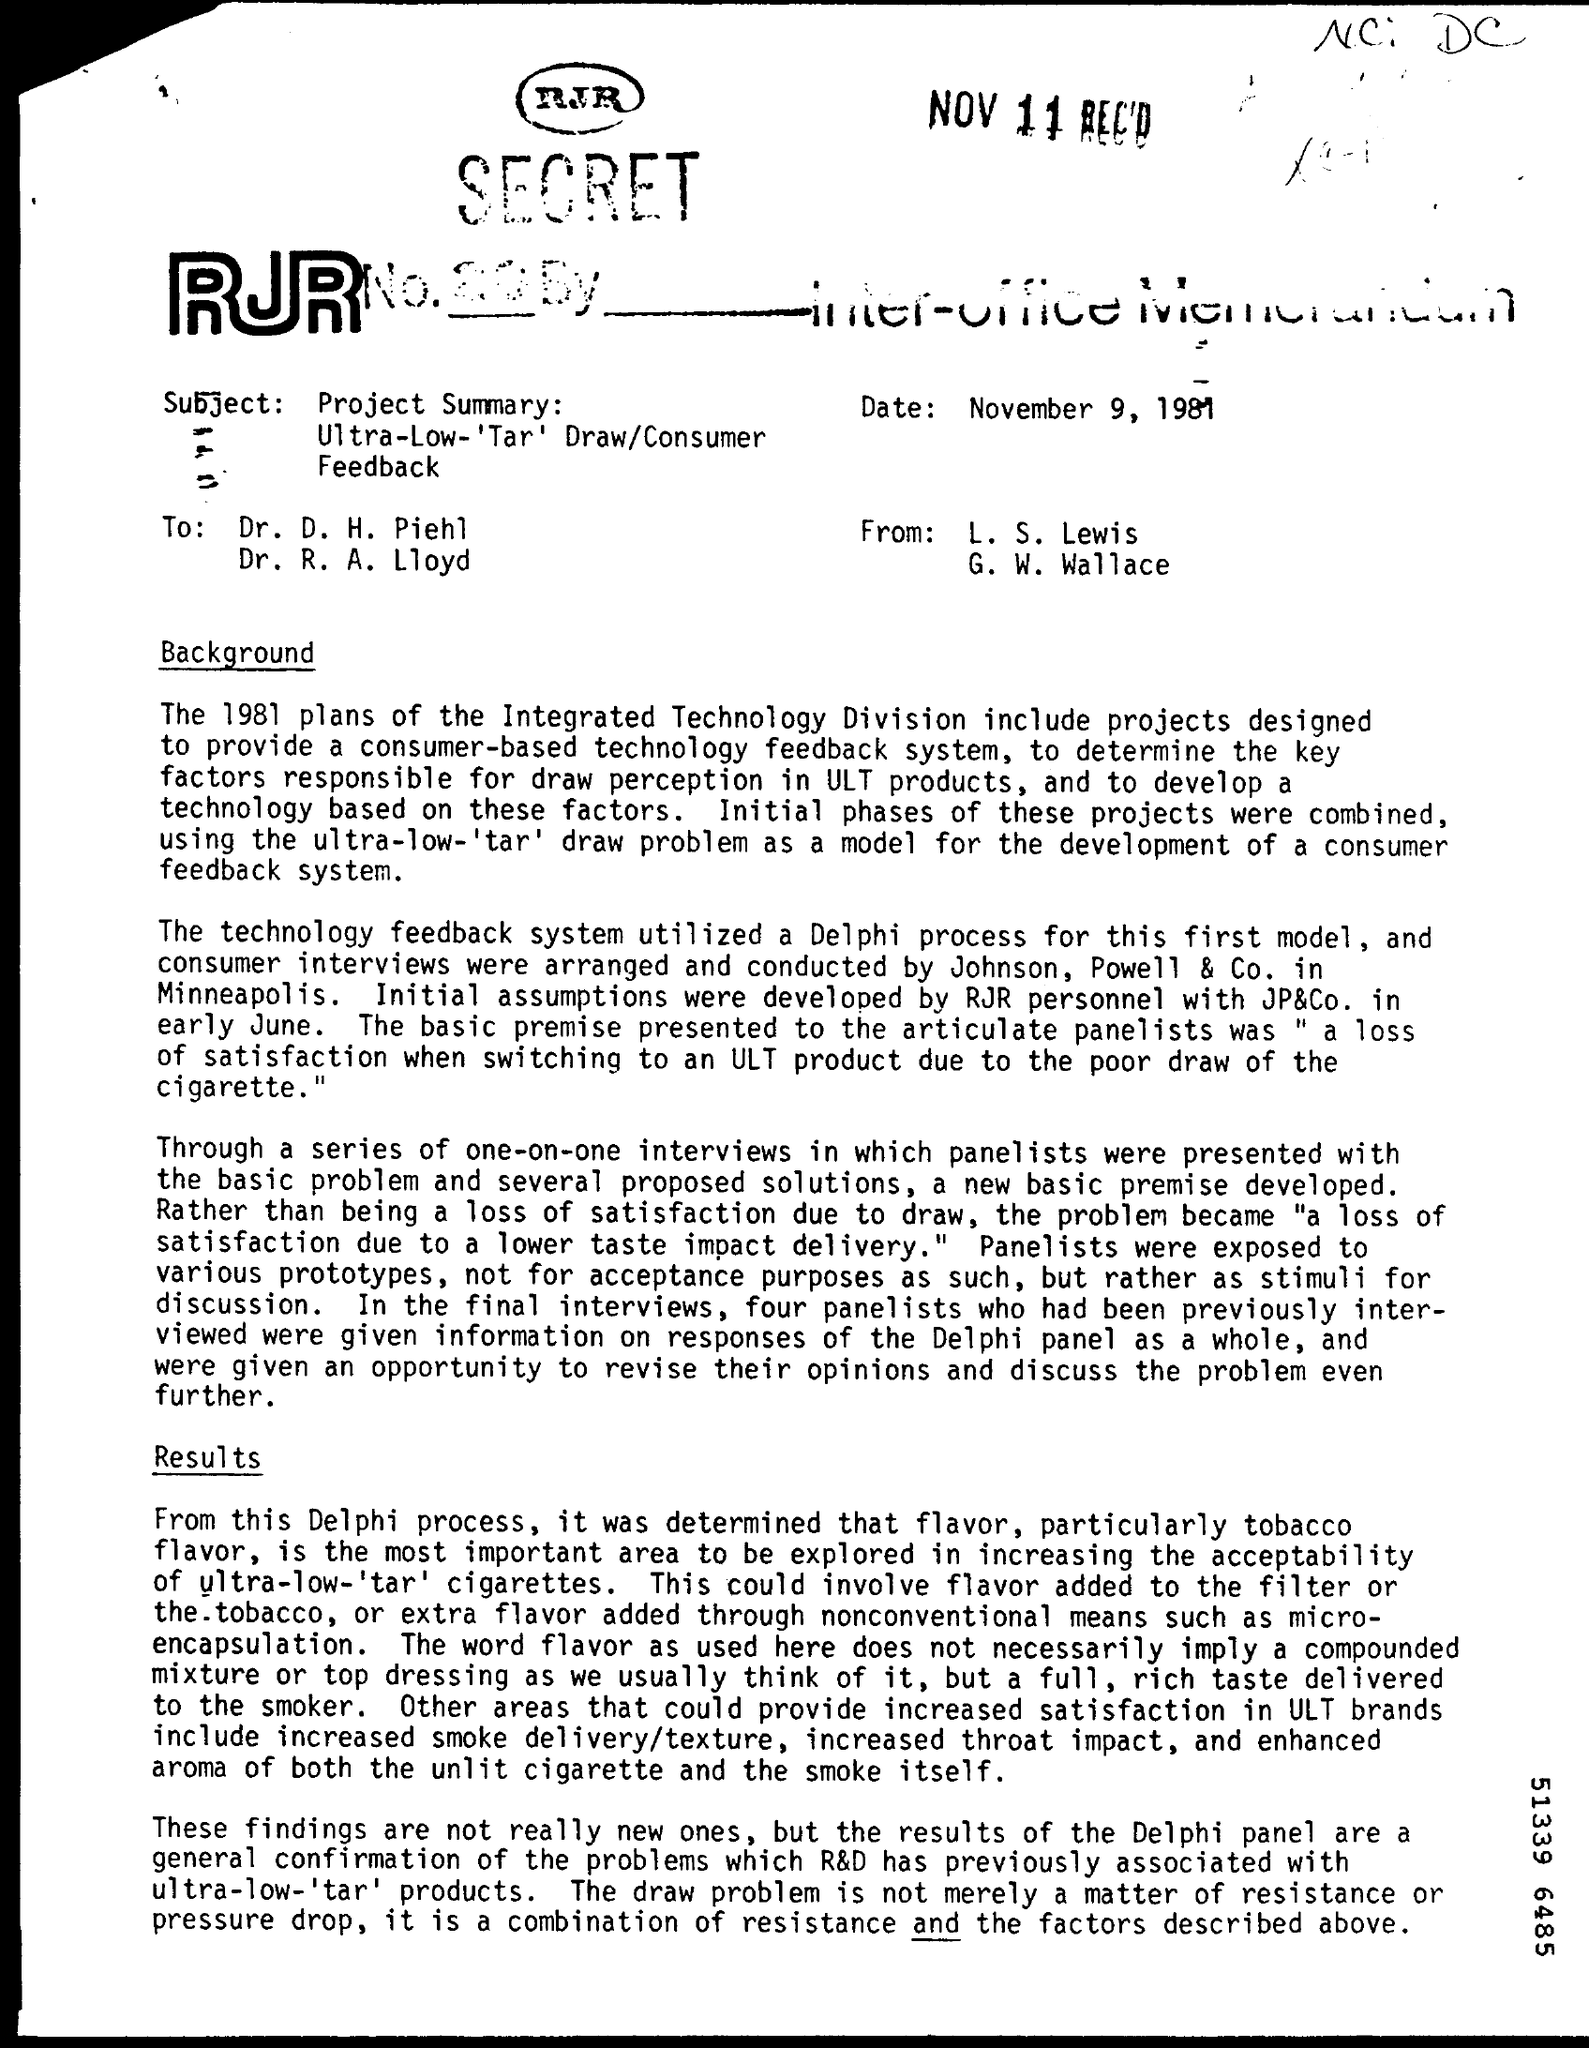Indicate a few pertinent items in this graphic. The technology feedback system utilized the Delphi process, a structured communication technique in which a questionnaire is repeatedly administered to a panel of experts until consensus is reached. 